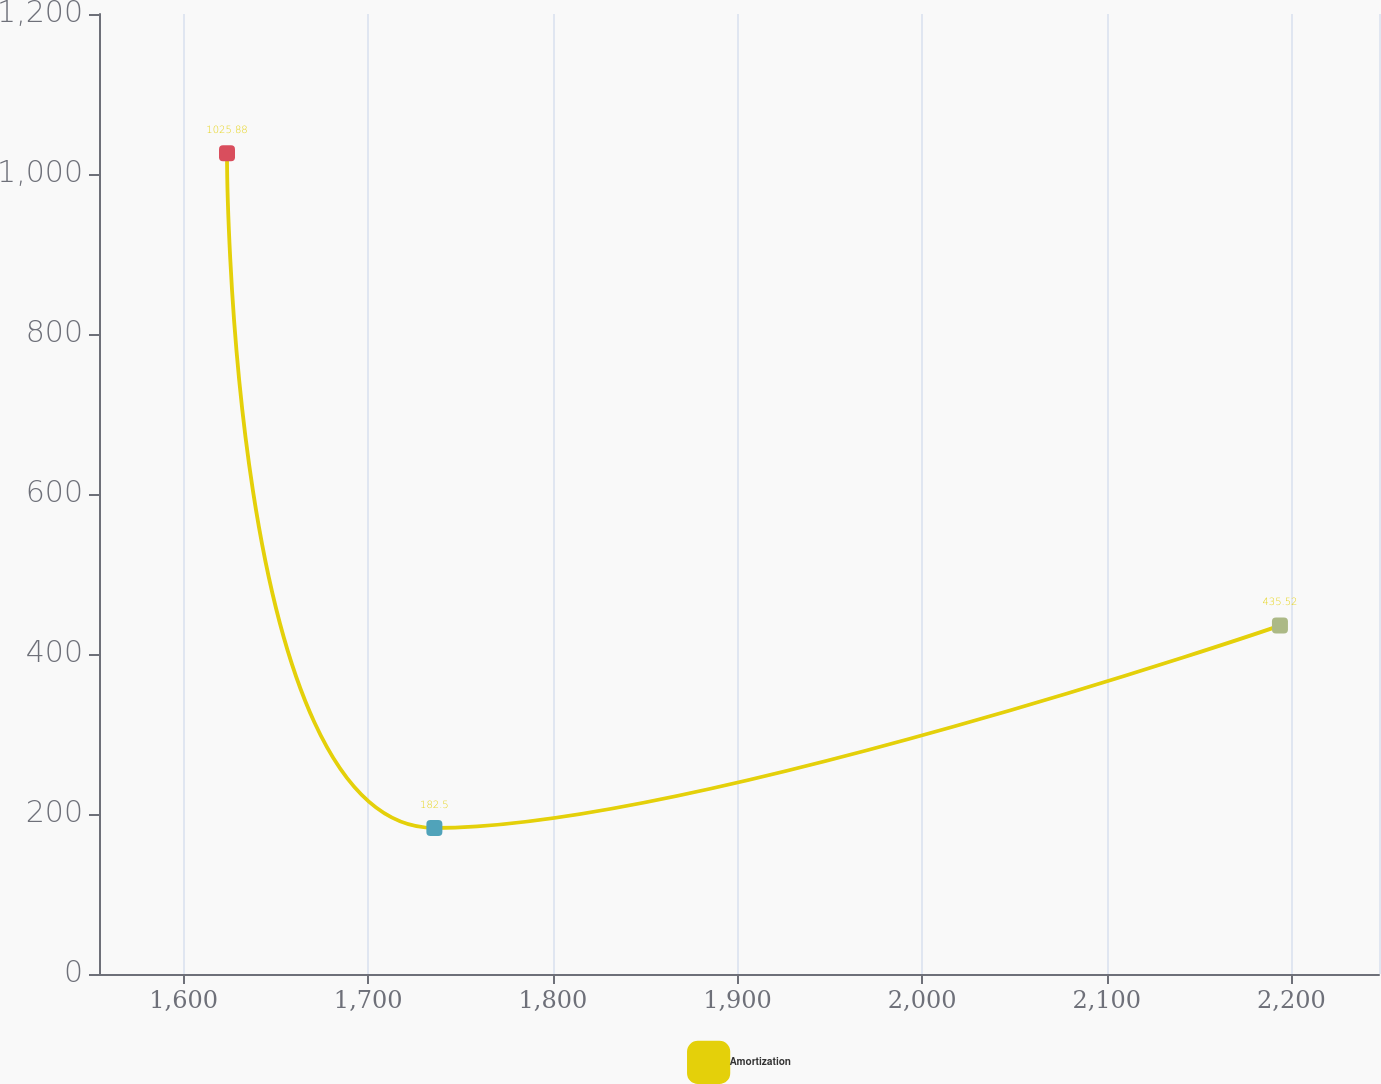Convert chart to OTSL. <chart><loc_0><loc_0><loc_500><loc_500><line_chart><ecel><fcel>Amortization<nl><fcel>1623.51<fcel>1025.88<nl><fcel>1735.83<fcel>182.5<nl><fcel>2193.8<fcel>435.52<nl><fcel>2255.29<fcel>266.84<nl><fcel>2316.78<fcel>351.18<nl></chart> 